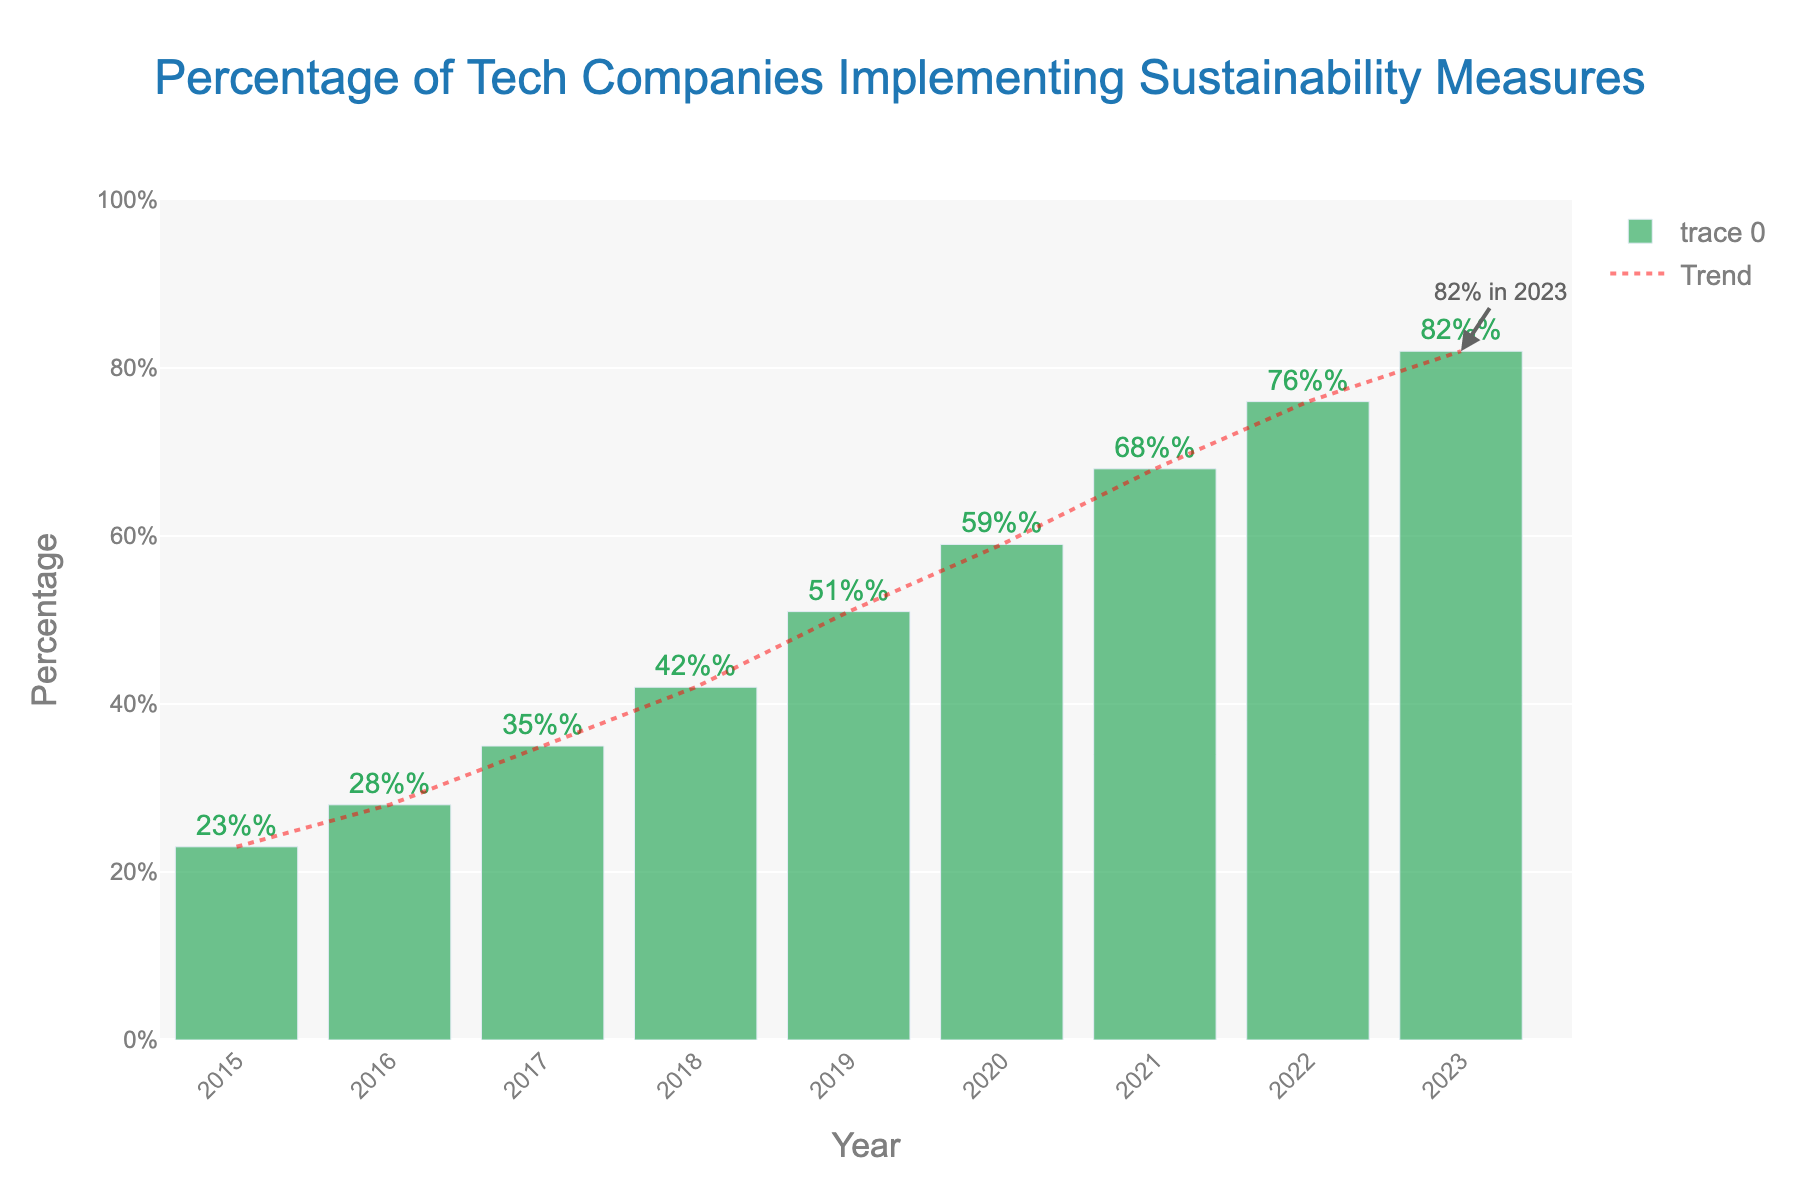What's the percentage increase in tech companies implementing sustainability measures from 2015 to 2023? First, find the percentage for 2015, which is 23%. Then, find the percentage for 2023, which is 82%. Calculate the increase: 82% - 23% = 59%.
Answer: 59% How does the percentage change between 2017 and 2018 compare to the change between 2018 and 2019? First, find the percentages: 2017 is 35%, 2018 is 42%, and 2019 is 51%. The change from 2017 to 2018 is 42% - 35% = 7%. The change from 2018 to 2019 is 51% - 42% = 9%.
Answer: The change is larger between 2018 and 2019 What is the average percentage of tech companies implementing sustainability measures from 2015 to 2023? Add up all the percentages from 2015 to 2023 (23% + 28% + 35% + 42% + 51% + 59% + 68% + 76% + 82% = 464%) and divide by the number of years (9). 464% / 9 = approximately 51.56%.
Answer: 51.56% In which year did the percentage of tech companies implementing sustainability measures exceed 50%? Look for the first year where the percentage is above 50%. It is 2019 with a percentage of 51%.
Answer: 2019 Which year shows the highest percentage of tech companies implementing sustainability measures? The highest bar in the chart represents the year 2023 with 82%.
Answer: 2023 What is the difference in percentage between the years 2020 and 2022? Find the percentages: 2020 is 59% and 2022 is 76%. Calculate the difference: 76% - 59% = 17%.
Answer: 17% Describe the trend shown by the red dotted trend line on the chart. The red dotted line ascends steadily from left to right, indicating a consistent increase in the percentage of tech companies implementing sustainability measures.
Answer: Consistent increase What percentage of tech companies implemented sustainability measures in 2021? Look at the bar for the year 2021, which is labeled at 68%.
Answer: 68% What is the median percentage of tech companies implementing sustainability measures from 2015 to 2023? Arrange the percentages in ascending order and find the middle value: 23%, 28%, 35%, 42%, 51%, 59%, 68%, 76%, 82%. The middle value (median) is 51%.
Answer: 51% How much did the percentage increase from 2019 to 2023? Find the percentages for 2019 (51%) and 2023 (82%). Calculate the increase: 82% - 51% = 31%.
Answer: 31% 